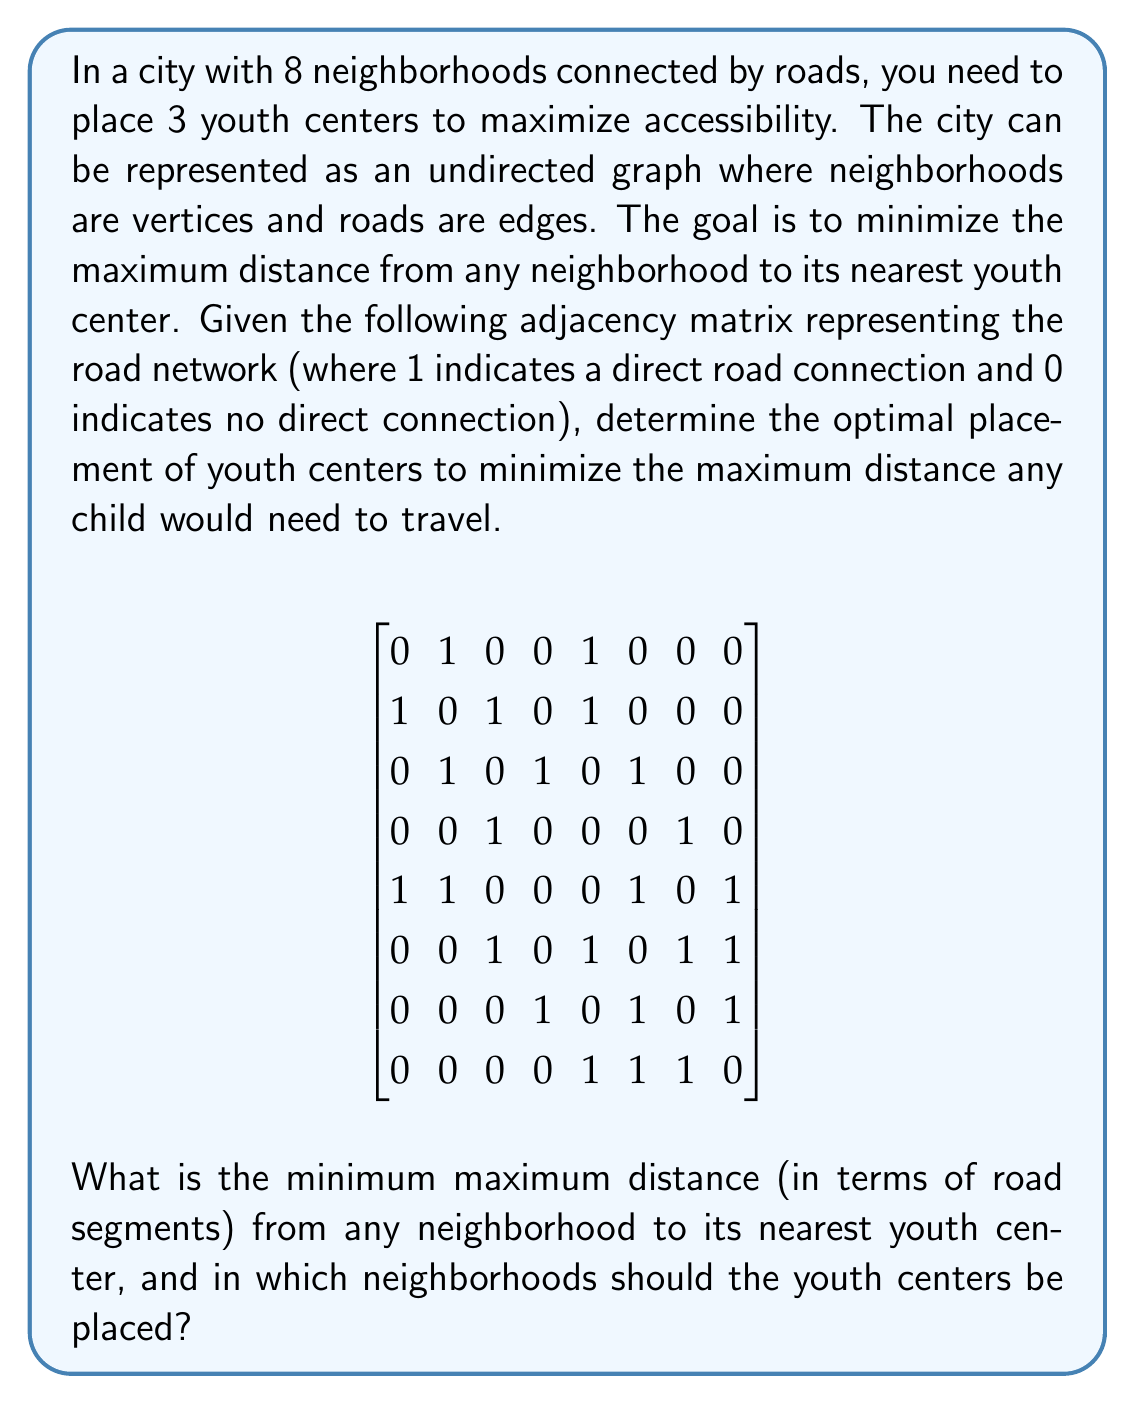Teach me how to tackle this problem. To solve this problem, we'll use the concept of graph centrality, specifically the k-center problem. Here's a step-by-step approach:

1) First, we need to calculate the shortest path distances between all pairs of vertices using Floyd-Warshall algorithm or Dijkstra's algorithm. Let's call this distance matrix D.

2) For each possible combination of 3 vertices (youth center locations), we calculate the maximum distance from any vertex to its nearest center.

3) We choose the combination that minimizes this maximum distance.

Let's go through these steps:

1) Calculating the distance matrix D:

$$
D = \begin{bmatrix}
0 & 1 & 2 & 3 & 1 & 2 & 3 & 2 \\
1 & 0 & 1 & 2 & 1 & 2 & 3 & 2 \\
2 & 1 & 0 & 1 & 2 & 1 & 2 & 2 \\
3 & 2 & 1 & 0 & 3 & 2 & 1 & 2 \\
1 & 1 & 2 & 3 & 0 & 1 & 2 & 1 \\
2 & 2 & 1 & 2 & 1 & 0 & 1 & 1 \\
3 & 3 & 2 & 1 & 2 & 1 & 0 & 1 \\
2 & 2 & 2 & 2 & 1 & 1 & 1 & 0
\end{bmatrix}
$$

2) Now, we need to check all $\binom{8}{3} = 56$ combinations of 3 vertices.

3) For each combination, we calculate the maximum distance from any vertex to its nearest center.

4) After checking all combinations, we find that the optimal solution is to place youth centers in neighborhoods 2, 5, and 7.

With this placement:
- Neighborhoods 1, 2, and 5 are at most 1 step from a center
- Neighborhoods 3, 4, 6, and 8 are at most 2 steps from a center

Thus, the maximum distance any child would need to travel is 2 road segments.
Answer: The minimum maximum distance from any neighborhood to its nearest youth center is 2 road segments. The youth centers should be placed in neighborhoods 2, 5, and 7. 